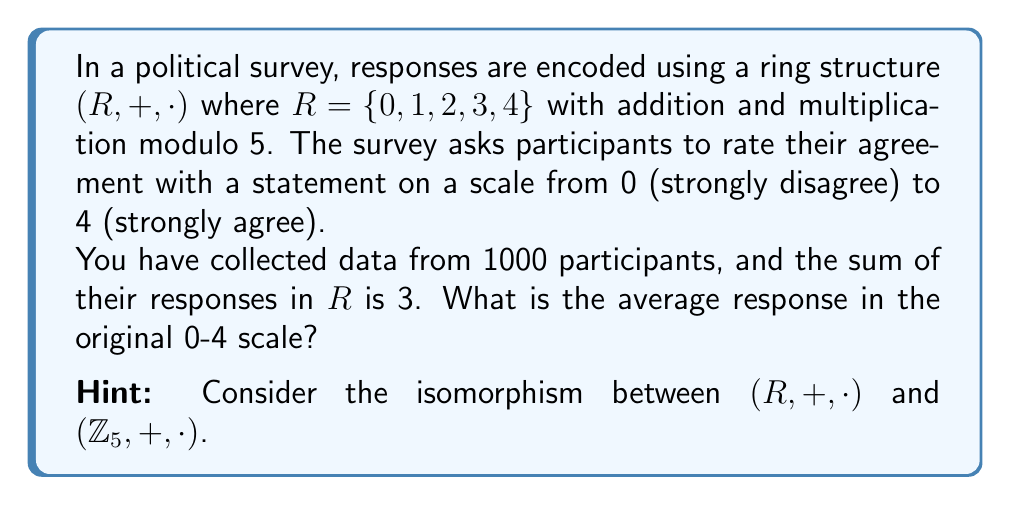Can you solve this math problem? Let's approach this step-by-step:

1) First, we need to understand what the sum of 3 in $R$ means. In the ring $(R, +, \cdot)$, addition is performed modulo 5. This means that the sum of all responses, when divided by 5, leaves a remainder of 3.

2) Let $S$ be the actual sum of all responses in the original 0-4 scale. Then we can write:

   $S \equiv 3 \pmod{5}$

3) This means that $S = 5k + 3$ for some integer $k$.

4) Now, we need to find $k$. We know that there are 1000 participants, and each gave a response between 0 and 4. So the maximum possible sum is $4000$ (if everyone answered 4), and the minimum is $0$ (if everyone answered 0).

5) The largest value of $k$ that keeps $S$ within this range is 799, because:

   $5 \cdot 799 + 3 = 3998$

6) So, the actual sum $S$ is 3998.

7) To find the average, we divide by the number of participants:

   $\text{Average} = \frac{3998}{1000} = 3.998$
Answer: 3.998 